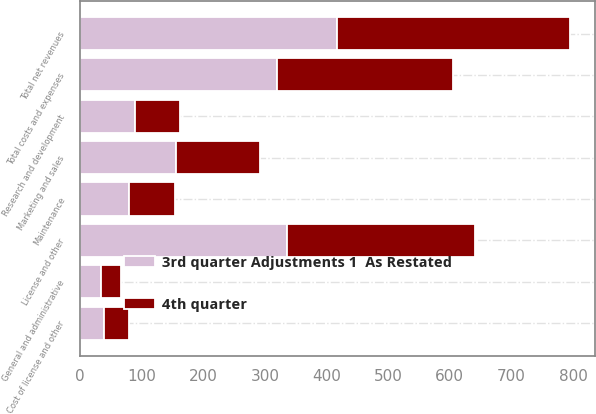Convert chart. <chart><loc_0><loc_0><loc_500><loc_500><stacked_bar_chart><ecel><fcel>License and other<fcel>Maintenance<fcel>Total net revenues<fcel>Cost of license and other<fcel>Marketing and sales<fcel>Research and development<fcel>General and administrative<fcel>Total costs and expenses<nl><fcel>3rd quarter Adjustments 1  As Restated<fcel>336.5<fcel>80.3<fcel>416.8<fcel>38.5<fcel>156<fcel>88.7<fcel>34.3<fcel>319.5<nl><fcel>4th quarter<fcel>304.4<fcel>73.9<fcel>378.3<fcel>40.8<fcel>136.4<fcel>74<fcel>32.5<fcel>285.3<nl></chart> 